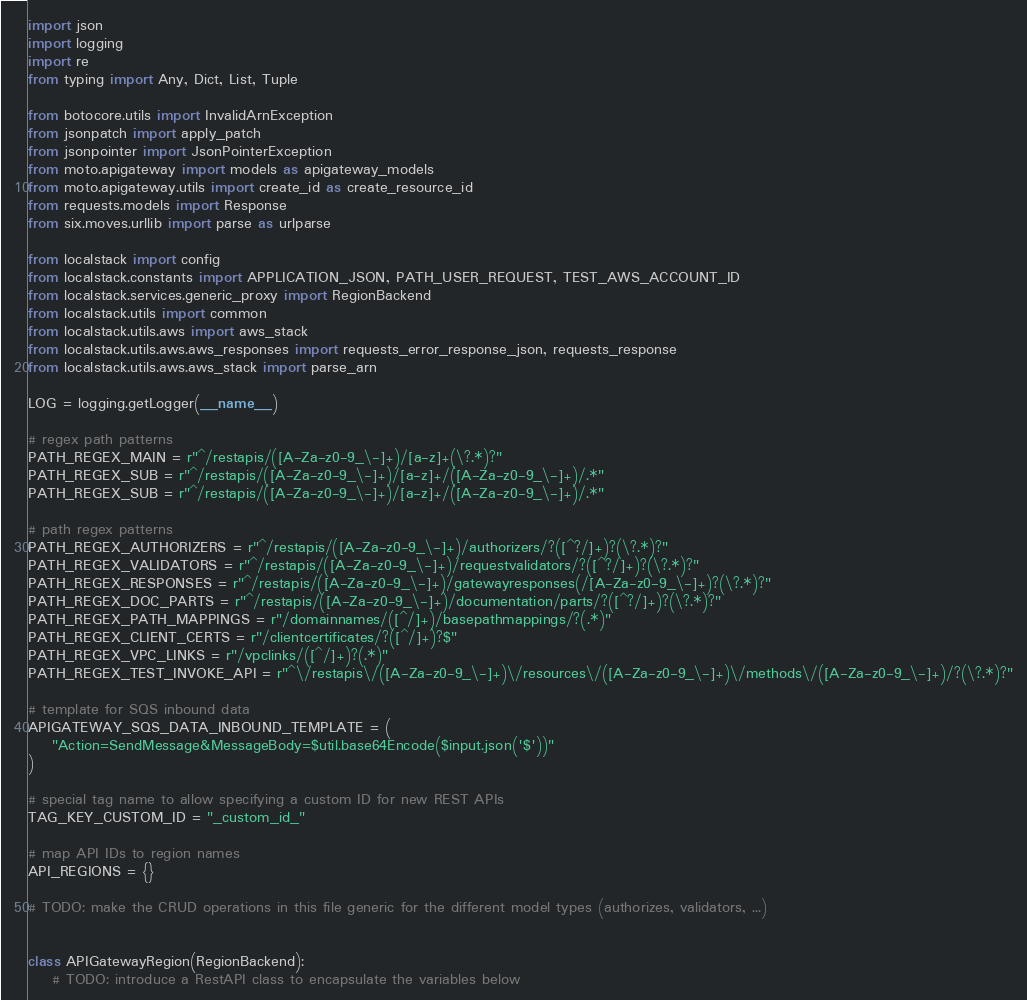Convert code to text. <code><loc_0><loc_0><loc_500><loc_500><_Python_>import json
import logging
import re
from typing import Any, Dict, List, Tuple

from botocore.utils import InvalidArnException
from jsonpatch import apply_patch
from jsonpointer import JsonPointerException
from moto.apigateway import models as apigateway_models
from moto.apigateway.utils import create_id as create_resource_id
from requests.models import Response
from six.moves.urllib import parse as urlparse

from localstack import config
from localstack.constants import APPLICATION_JSON, PATH_USER_REQUEST, TEST_AWS_ACCOUNT_ID
from localstack.services.generic_proxy import RegionBackend
from localstack.utils import common
from localstack.utils.aws import aws_stack
from localstack.utils.aws.aws_responses import requests_error_response_json, requests_response
from localstack.utils.aws.aws_stack import parse_arn

LOG = logging.getLogger(__name__)

# regex path patterns
PATH_REGEX_MAIN = r"^/restapis/([A-Za-z0-9_\-]+)/[a-z]+(\?.*)?"
PATH_REGEX_SUB = r"^/restapis/([A-Za-z0-9_\-]+)/[a-z]+/([A-Za-z0-9_\-]+)/.*"
PATH_REGEX_SUB = r"^/restapis/([A-Za-z0-9_\-]+)/[a-z]+/([A-Za-z0-9_\-]+)/.*"

# path regex patterns
PATH_REGEX_AUTHORIZERS = r"^/restapis/([A-Za-z0-9_\-]+)/authorizers/?([^?/]+)?(\?.*)?"
PATH_REGEX_VALIDATORS = r"^/restapis/([A-Za-z0-9_\-]+)/requestvalidators/?([^?/]+)?(\?.*)?"
PATH_REGEX_RESPONSES = r"^/restapis/([A-Za-z0-9_\-]+)/gatewayresponses(/[A-Za-z0-9_\-]+)?(\?.*)?"
PATH_REGEX_DOC_PARTS = r"^/restapis/([A-Za-z0-9_\-]+)/documentation/parts/?([^?/]+)?(\?.*)?"
PATH_REGEX_PATH_MAPPINGS = r"/domainnames/([^/]+)/basepathmappings/?(.*)"
PATH_REGEX_CLIENT_CERTS = r"/clientcertificates/?([^/]+)?$"
PATH_REGEX_VPC_LINKS = r"/vpclinks/([^/]+)?(.*)"
PATH_REGEX_TEST_INVOKE_API = r"^\/restapis\/([A-Za-z0-9_\-]+)\/resources\/([A-Za-z0-9_\-]+)\/methods\/([A-Za-z0-9_\-]+)/?(\?.*)?"

# template for SQS inbound data
APIGATEWAY_SQS_DATA_INBOUND_TEMPLATE = (
    "Action=SendMessage&MessageBody=$util.base64Encode($input.json('$'))"
)

# special tag name to allow specifying a custom ID for new REST APIs
TAG_KEY_CUSTOM_ID = "_custom_id_"

# map API IDs to region names
API_REGIONS = {}

# TODO: make the CRUD operations in this file generic for the different model types (authorizes, validators, ...)


class APIGatewayRegion(RegionBackend):
    # TODO: introduce a RestAPI class to encapsulate the variables below</code> 